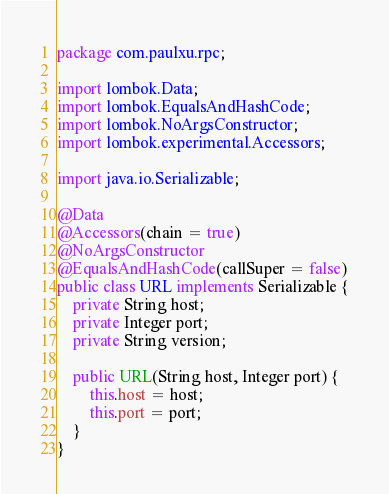Convert code to text. <code><loc_0><loc_0><loc_500><loc_500><_Java_>package com.paulxu.rpc;

import lombok.Data;
import lombok.EqualsAndHashCode;
import lombok.NoArgsConstructor;
import lombok.experimental.Accessors;

import java.io.Serializable;

@Data
@Accessors(chain = true)
@NoArgsConstructor
@EqualsAndHashCode(callSuper = false)
public class URL implements Serializable {
    private String host;
    private Integer port;
    private String version;

    public URL(String host, Integer port) {
        this.host = host;
        this.port = port;
    }
}
</code> 